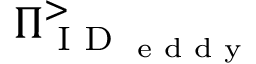<formula> <loc_0><loc_0><loc_500><loc_500>\Pi _ { I D _ { e d d y } } ^ { > }</formula> 